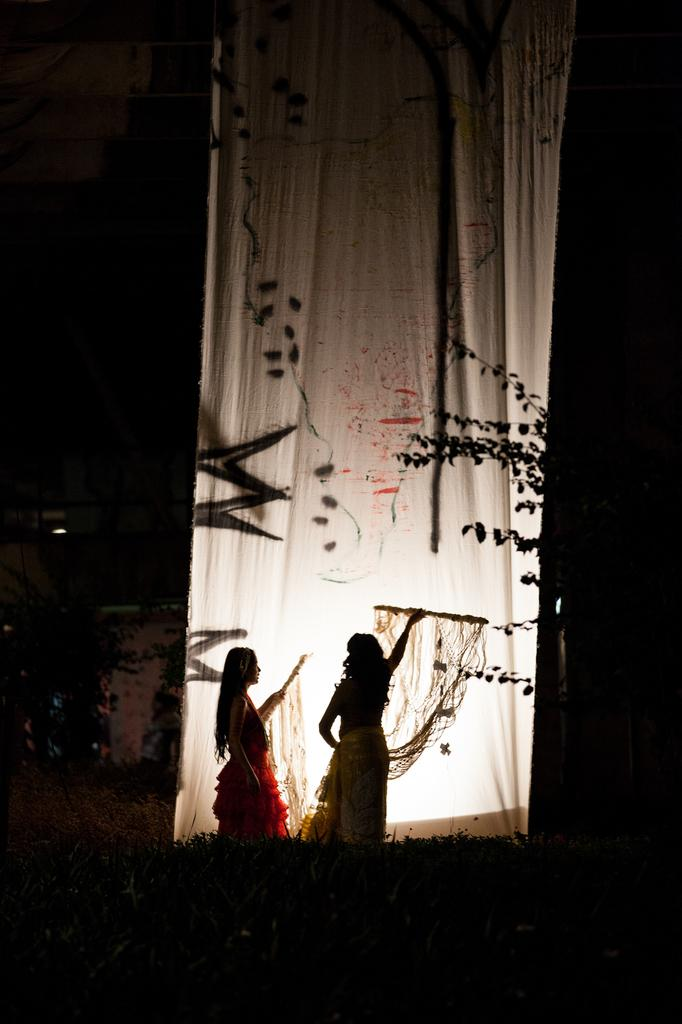What is the main object in the center of the image? There is a cloth in the center of the image. What are the two ladies doing in the image? The two ladies are dancing at the bottom of the image. What type of natural elements can be seen in the image? There are trees visible in the image. What type of illumination is present in the image? There are lights present in the image. What type of yarn is being used to create the order in the image? There is no yarn or order present in the image; it features a cloth, two ladies dancing, trees, and lights. 